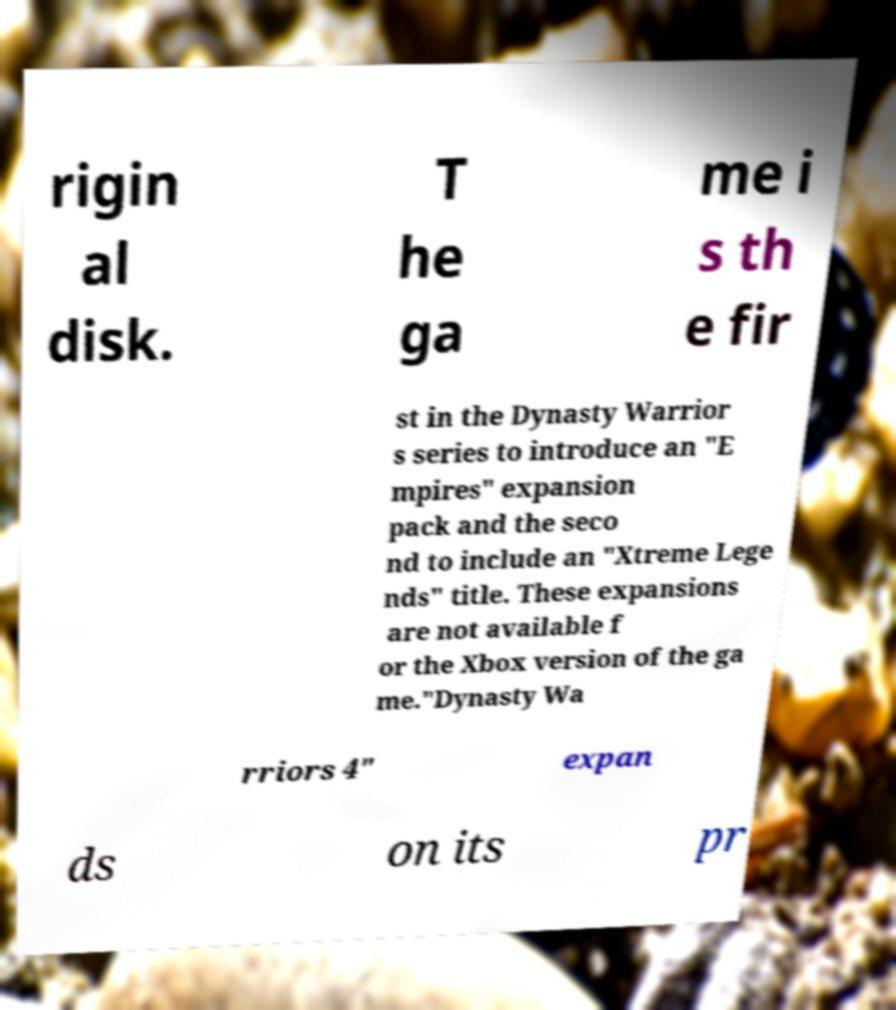I need the written content from this picture converted into text. Can you do that? rigin al disk. T he ga me i s th e fir st in the Dynasty Warrior s series to introduce an "E mpires" expansion pack and the seco nd to include an "Xtreme Lege nds" title. These expansions are not available f or the Xbox version of the ga me."Dynasty Wa rriors 4" expan ds on its pr 